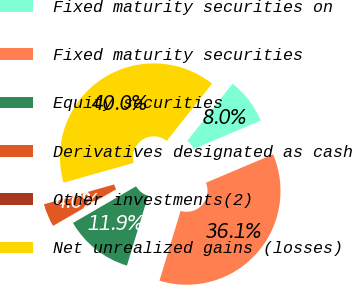Convert chart to OTSL. <chart><loc_0><loc_0><loc_500><loc_500><pie_chart><fcel>Fixed maturity securities on<fcel>Fixed maturity securities<fcel>Equity securities<fcel>Derivatives designated as cash<fcel>Other investments(2)<fcel>Net unrealized gains (losses)<nl><fcel>7.97%<fcel>36.06%<fcel>11.94%<fcel>3.99%<fcel>0.01%<fcel>40.04%<nl></chart> 